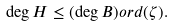Convert formula to latex. <formula><loc_0><loc_0><loc_500><loc_500>\deg H \leq ( \deg B ) o r d ( \zeta ) .</formula> 